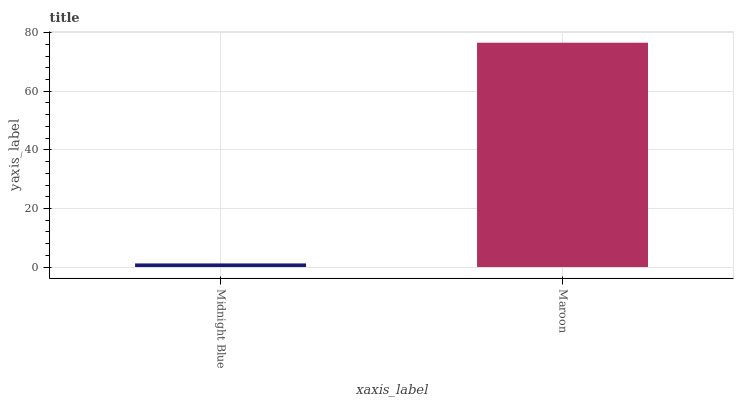Is Maroon the minimum?
Answer yes or no. No. Is Maroon greater than Midnight Blue?
Answer yes or no. Yes. Is Midnight Blue less than Maroon?
Answer yes or no. Yes. Is Midnight Blue greater than Maroon?
Answer yes or no. No. Is Maroon less than Midnight Blue?
Answer yes or no. No. Is Maroon the high median?
Answer yes or no. Yes. Is Midnight Blue the low median?
Answer yes or no. Yes. Is Midnight Blue the high median?
Answer yes or no. No. Is Maroon the low median?
Answer yes or no. No. 